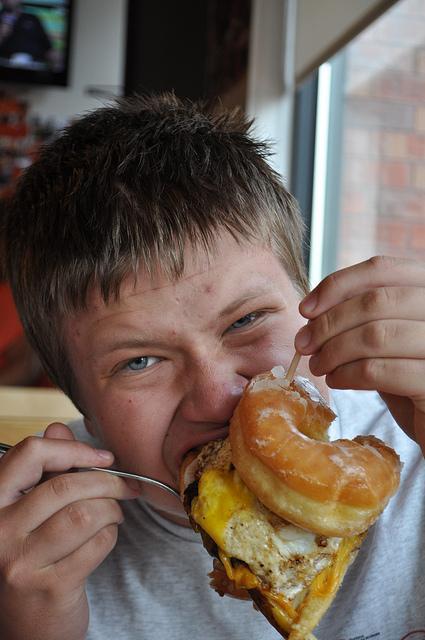Is the caption "The sandwich consists of the donut." a true representation of the image?
Answer yes or no. Yes. 